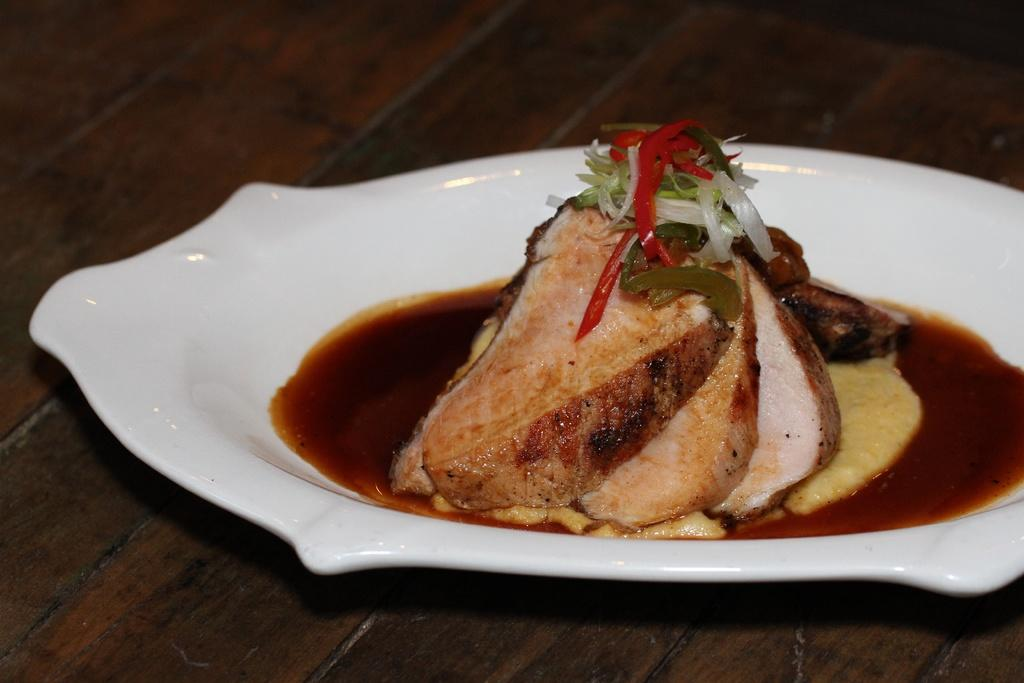What is present on the plate in the image? There is food on the plate in the image. What accompanies the food on the plate? There is sauce on the plate. What type of surface is visible at the bottom of the image? There is a wooden surface at the bottom of the image. What is the chance of the hook being used to serve the food on the plate? There is no hook present in the image, so it cannot be used to serve the food. 